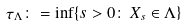Convert formula to latex. <formula><loc_0><loc_0><loc_500><loc_500>\tau _ { \Lambda } \colon = \inf \{ s > 0 \colon \, X _ { s } \in \Lambda \}</formula> 